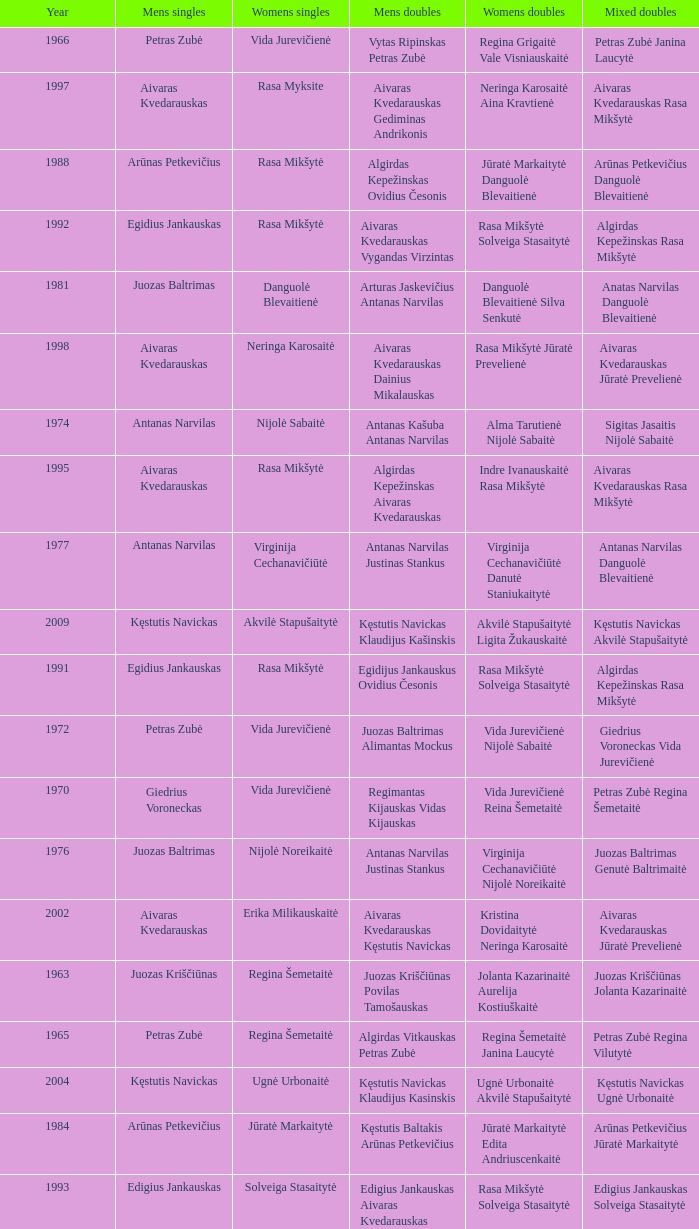Parse the table in full. {'header': ['Year', 'Mens singles', 'Womens singles', 'Mens doubles', 'Womens doubles', 'Mixed doubles'], 'rows': [['1966', 'Petras Zubė', 'Vida Jurevičienė', 'Vytas Ripinskas Petras Zubė', 'Regina Grigaitė Vale Visniauskaitė', 'Petras Zubė Janina Laucytė'], ['1997', 'Aivaras Kvedarauskas', 'Rasa Myksite', 'Aivaras Kvedarauskas Gediminas Andrikonis', 'Neringa Karosaitė Aina Kravtienė', 'Aivaras Kvedarauskas Rasa Mikšytė'], ['1988', 'Arūnas Petkevičius', 'Rasa Mikšytė', 'Algirdas Kepežinskas Ovidius Česonis', 'Jūratė Markaitytė Danguolė Blevaitienė', 'Arūnas Petkevičius Danguolė Blevaitienė'], ['1992', 'Egidius Jankauskas', 'Rasa Mikšytė', 'Aivaras Kvedarauskas Vygandas Virzintas', 'Rasa Mikšytė Solveiga Stasaitytė', 'Algirdas Kepežinskas Rasa Mikšytė'], ['1981', 'Juozas Baltrimas', 'Danguolė Blevaitienė', 'Arturas Jaskevičius Antanas Narvilas', 'Danguolė Blevaitienė Silva Senkutė', 'Anatas Narvilas Danguolė Blevaitienė'], ['1998', 'Aivaras Kvedarauskas', 'Neringa Karosaitė', 'Aivaras Kvedarauskas Dainius Mikalauskas', 'Rasa Mikšytė Jūratė Prevelienė', 'Aivaras Kvedarauskas Jūratė Prevelienė'], ['1974', 'Antanas Narvilas', 'Nijolė Sabaitė', 'Antanas Kašuba Antanas Narvilas', 'Alma Tarutienė Nijolė Sabaitė', 'Sigitas Jasaitis Nijolė Sabaitė'], ['1995', 'Aivaras Kvedarauskas', 'Rasa Mikšytė', 'Algirdas Kepežinskas Aivaras Kvedarauskas', 'Indre Ivanauskaitė Rasa Mikšytė', 'Aivaras Kvedarauskas Rasa Mikšytė'], ['1977', 'Antanas Narvilas', 'Virginija Cechanavičiūtė', 'Antanas Narvilas Justinas Stankus', 'Virginija Cechanavičiūtė Danutė Staniukaitytė', 'Antanas Narvilas Danguolė Blevaitienė'], ['2009', 'Kęstutis Navickas', 'Akvilė Stapušaitytė', 'Kęstutis Navickas Klaudijus Kašinskis', 'Akvilė Stapušaitytė Ligita Žukauskaitė', 'Kęstutis Navickas Akvilė Stapušaitytė'], ['1991', 'Egidius Jankauskas', 'Rasa Mikšytė', 'Egidijus Jankauskus Ovidius Česonis', 'Rasa Mikšytė Solveiga Stasaitytė', 'Algirdas Kepežinskas Rasa Mikšytė'], ['1972', 'Petras Zubė', 'Vida Jurevičienė', 'Juozas Baltrimas Alimantas Mockus', 'Vida Jurevičienė Nijolė Sabaitė', 'Giedrius Voroneckas Vida Jurevičienė'], ['1970', 'Giedrius Voroneckas', 'Vida Jurevičienė', 'Regimantas Kijauskas Vidas Kijauskas', 'Vida Jurevičienė Reina Šemetaitė', 'Petras Zubė Regina Šemetaitė'], ['1976', 'Juozas Baltrimas', 'Nijolė Noreikaitė', 'Antanas Narvilas Justinas Stankus', 'Virginija Cechanavičiūtė Nijolė Noreikaitė', 'Juozas Baltrimas Genutė Baltrimaitė'], ['2002', 'Aivaras Kvedarauskas', 'Erika Milikauskaitė', 'Aivaras Kvedarauskas Kęstutis Navickas', 'Kristina Dovidaitytė Neringa Karosaitė', 'Aivaras Kvedarauskas Jūratė Prevelienė'], ['1963', 'Juozas Kriščiūnas', 'Regina Šemetaitė', 'Juozas Kriščiūnas Povilas Tamošauskas', 'Jolanta Kazarinaitė Aurelija Kostiuškaitė', 'Juozas Kriščiūnas Jolanta Kazarinaitė'], ['1965', 'Petras Zubė', 'Regina Šemetaitė', 'Algirdas Vitkauskas Petras Zubė', 'Regina Šemetaitė Janina Laucytė', 'Petras Zubė Regina Vilutytė'], ['2004', 'Kęstutis Navickas', 'Ugnė Urbonaitė', 'Kęstutis Navickas Klaudijus Kasinskis', 'Ugnė Urbonaitė Akvilė Stapušaitytė', 'Kęstutis Navickas Ugnė Urbonaitė'], ['1984', 'Arūnas Petkevičius', 'Jūratė Markaitytė', 'Kęstutis Baltakis Arūnas Petkevičius', 'Jūratė Markaitytė Edita Andriuscenkaitė', 'Arūnas Petkevičius Jūratė Markaitytė'], ['1993', 'Edigius Jankauskas', 'Solveiga Stasaitytė', 'Edigius Jankauskas Aivaras Kvedarauskas', 'Rasa Mikšytė Solveiga Stasaitytė', 'Edigius Jankauskas Solveiga Stasaitytė'], ['1978', 'Juozas Baltrimas', 'Virginija Cechanavičiūtė', 'Arturas Jaskevičius Justinas Stankus', 'Virginija Cechanavičiūtė Asta Šimbelytė', 'Rimas Liubartas Virginija Cechanavičiūtė'], ['2000', 'Aivaras Kvedarauskas', 'Erika Milikauskaitė', 'Aivaras Kvedarauskas Donatas Vievesis', 'Kristina Dovidaitytė Neringa Karosaitė', 'Aivaras Kvedarauskas Jūratė Prevelienė'], ['1967', 'Juozas Baltrimas', 'Vida Jurevičienė', 'Vytas Ripinskas Petras Zubė', 'Vida Jurevičienė Vale Viniauskaitė', 'Petras Zubė Regina Minelgienė'], ['1979', 'Antanas Narvilas', 'Virginija Cechanavičiūtė', 'Juozas Baltrimas Kęstutis Dabravolskis', 'Virginija Cechanavičiūtė Milda Taraskevičiūtė', 'Juozas Baltrimas Genutė Baltrimaitė'], ['1996', 'Aivaras Kvedarauskas', 'Rasa Myksite', 'Aivaras Kvedarauskas Donatas Vievesis', 'Indre Ivanauskaitė Rasa Mikšytė', 'Aivaras Kvedarauskas Rasa Mikšytė'], ['1975', 'Juozas Baltrimas', 'Nijolė Sabaitė', 'Antanas Narvilas Justinas Stankus', 'Genutė Baltrimaitė Danutė Staniukaitytė', 'Juozas Baltrimas Genutė Baltrimaitė'], ['2003', 'Aivaras Kvedarauskas', 'Ugnė Urbonaitė', 'Aivaras Kvedarauskas Dainius Mikalauskas', 'Ugnė Urbonaitė Kristina Dovidaitytė', 'Aivaras Kvedarauskas Ugnė Urbonaitė'], ['1987', 'Egidijus Jankauskas', 'Jūratė Markaitytė', 'Kęstutis Baltakis Arūnas Petkevičius', 'Jūratė Markaitytė Danguolė Blevaitienė', 'Egidijus Jankauskas Danguolė Blevaitienė'], ['2005', 'Kęstutis Navickas', 'Ugnė Urbonaitė', 'Kęstutis Navickas Klaudijus Kasinskis', 'Ugnė Urbonaitė Akvilė Stapušaitytė', 'Donatas Narvilas Kristina Dovidaitytė'], ['2008', 'Kęstutis Navickas', 'Akvilė Stapušaitytė', 'Paulius Geležiūnas Ramūnas Stapušaitis', 'Gerda Voitechovskaja Kristina Dovidaitytė', 'Kęstutis Navickas Akvilė Stapušaitytė'], ['1969', 'Petras Zubė', 'Valė Viskinauskaitė', 'Antanas Narvilas Regimantas Kijauskas', 'Regina Šemetaitė Salvija Petronytė', 'Petras Zubė Regina Minelgienė'], ['1964', 'Juozas Kriščiūnas', 'Jolanta Kazarinaitė', 'Juozas Kriščiūnas Vladas Rybakovas', 'Jolanta Kazarinaitė Valentina Guseva', 'Vladas Rybakovas Valentina Gusva'], ['1990', 'Aivaras Kvedarauskas', 'Rasa Mikšytė', 'Algirdas Kepežinskas Ovidius Česonis', 'Jūratė Markaitytė Danguolė Blevaitienė', 'Aivaras Kvedarauskas Rasa Mikšytė'], ['1985', 'Arūnas Petkevičius', 'Jūratė Markaitytė', 'Kęstutis Baltakis Arūnas Petkevičius', 'Jūratė Markaitytė Silva Senkutė', 'Arūnas Petkevičius Jūratė Markaitytė'], ['2007', 'Kęstutis Navickas', 'Akvilė Stapušaitytė', 'Kęstutis Navickas Klaudijus Kašinskis', 'Gerda Voitechovskaja Kristina Dovidaitytė', 'Kęstutis Navickas Indrė Starevičiūtė'], ['1982', 'Juozas Baltrimas', 'Danguolė Blevaitienė', 'Juozas Baltrimas Sigitas Jasaitis', 'Danguolė Blevaitienė Silva Senkutė', 'Anatas Narvilas Danguolė Blevaitienė'], ['1980', 'Arturas Jaskevičius', 'Milda Taraskevičiūtė', 'Juozas Baltrimas Kęstutis Baltakis', 'Asta Šimbelytė Milda Taraskevičiūtė', 'Sigitas Jasaitis Silva Senkutė'], ['1989', 'Ovidijus Cesonis', 'Aušrinė Gabrenaitė', 'Egidijus Jankauskus Ovidius Česonis', 'Aušrinė Gebranaitė Rasa Mikšytė', 'Egidijus Jankauskas Aušrinė Gabrenaitė'], ['1973', 'Juozas Baltrimas', 'Nijolė Sabaitė', 'Antanas Kašuba Petras Zubė', 'Danutė Staniukaitytė Nijolė Sabaitė', 'Petras Zubė Drazina Dovidavičiūtė'], ['1994', 'Aivaras Kvedarauskas', 'Aina Kravtienė', 'Aivaras Kvedarauskas Ovidijus Zukauskas', 'Indre Ivanauskaitė Rasa Mikšytė', 'Aivaras Kvedarauskas Indze Ivanauskaitė'], ['1968', 'Juozas Baltrimas', 'Vida Jurevičienė', 'Juozas Kriščiūnas Petras Zubė', 'Vida Jurevičienė Undinė Jagelaitė', 'Juozas Kriščiūnas Vida Jurevičienė'], ['1999', 'Aivaras Kvedarauskas', 'Erika Milikauskaitė', 'Aivaras Kvedarauskas Dainius Mikalauskas', 'Rasa Mikšytė Jūratė Prevelienė', 'Aivaras Kvedarauskas Rasa Mikšytė'], ['1971', 'Petras Zubė', 'Vida Jurevičienė', 'Antanas Narvilas Petras Zubė', 'Vida Jurevičienė Undinė Jagelaitė', 'Petras Zubė Regina Šemetaitė'], ['2006', 'Šarūnas Bilius', 'Akvilė Stapušaitytė', 'Deividas Butkus Klaudijus Kašinskis', 'Akvilė Stapušaitytė Ligita Žukauskaitė', 'Donatas Narvilas Kristina Dovidaitytė'], ['1983', 'Arūnas Petkevičius', 'Jūratė Markaitytė', 'Kęstutis Baltakis Arūnas Petkevičius', 'Jūratė Markaitytė Jūratė Lazauninkaitė', 'Kstutis Baltakis Jūratė Andriuscenkaitė'], ['1986', 'Arūnas Petkevičius', 'Jūratė Markaitytė', 'Kęstutis Baltakis Arūnas Petkevičius', 'Jūratė Markaitytė Aušrinė Gebranaitė', 'Egidijus Jankauskas Jūratė Markaitytė'], ['2001', 'Aivaras Kvedarauskas', 'Neringa Karosaitė', 'Aivaras Kvedarauskas Juozas Spelveris', 'Kristina Dovidaitytė Neringa Karosaitė', 'Aivaras Kvedarauskas Ligita Zakauskaitė']]} What was the first year of the Lithuanian National Badminton Championships? 1963.0. 